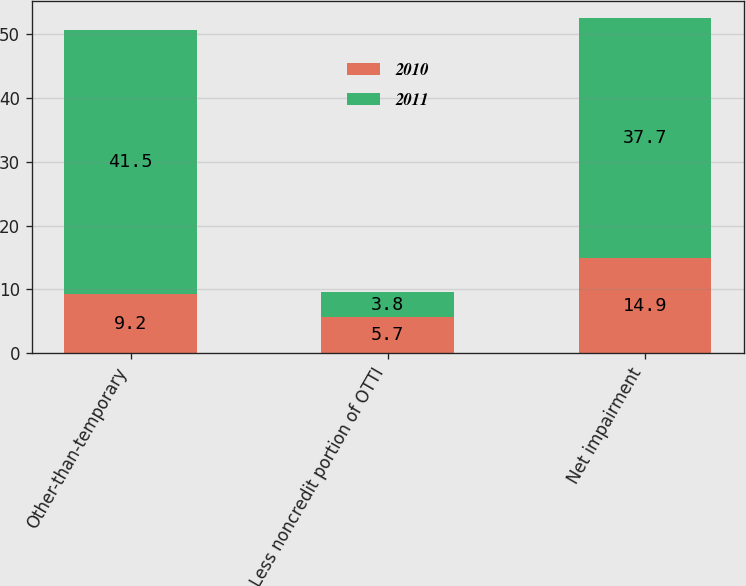Convert chart to OTSL. <chart><loc_0><loc_0><loc_500><loc_500><stacked_bar_chart><ecel><fcel>Other-than-temporary<fcel>Less noncredit portion of OTTI<fcel>Net impairment<nl><fcel>2010<fcel>9.2<fcel>5.7<fcel>14.9<nl><fcel>2011<fcel>41.5<fcel>3.8<fcel>37.7<nl></chart> 